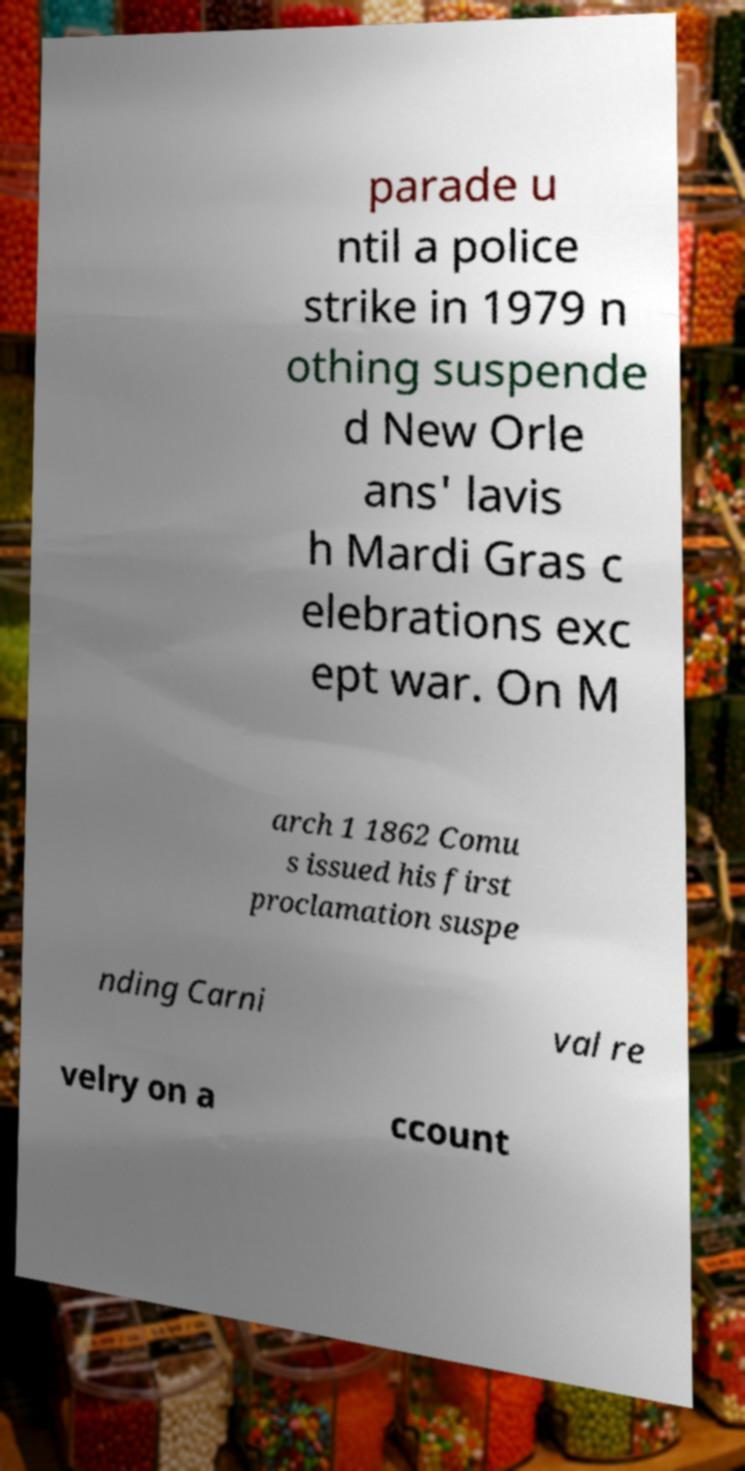Can you read and provide the text displayed in the image?This photo seems to have some interesting text. Can you extract and type it out for me? parade u ntil a police strike in 1979 n othing suspende d New Orle ans' lavis h Mardi Gras c elebrations exc ept war. On M arch 1 1862 Comu s issued his first proclamation suspe nding Carni val re velry on a ccount 